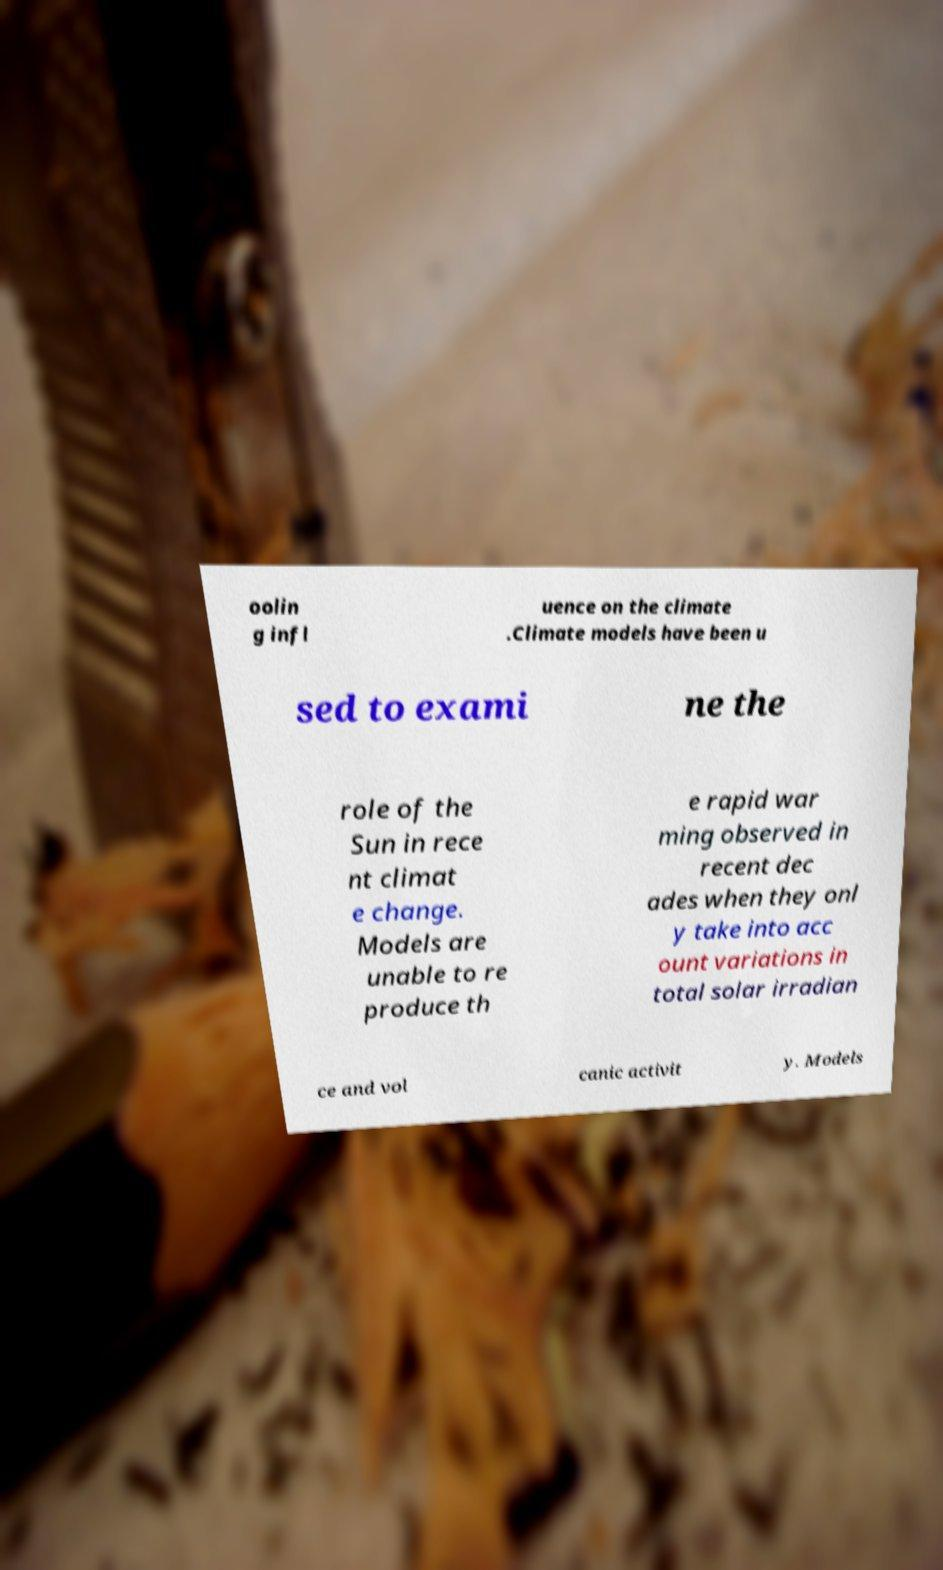Could you assist in decoding the text presented in this image and type it out clearly? oolin g infl uence on the climate .Climate models have been u sed to exami ne the role of the Sun in rece nt climat e change. Models are unable to re produce th e rapid war ming observed in recent dec ades when they onl y take into acc ount variations in total solar irradian ce and vol canic activit y. Models 